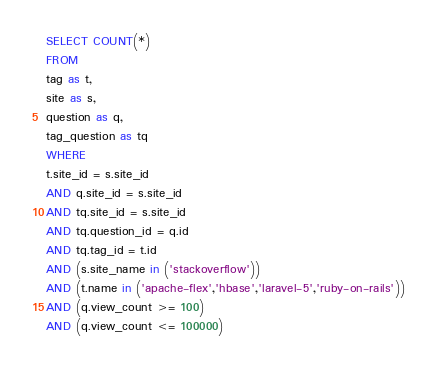<code> <loc_0><loc_0><loc_500><loc_500><_SQL_>SELECT COUNT(*)
FROM
tag as t,
site as s,
question as q,
tag_question as tq
WHERE
t.site_id = s.site_id
AND q.site_id = s.site_id
AND tq.site_id = s.site_id
AND tq.question_id = q.id
AND tq.tag_id = t.id
AND (s.site_name in ('stackoverflow'))
AND (t.name in ('apache-flex','hbase','laravel-5','ruby-on-rails'))
AND (q.view_count >= 100)
AND (q.view_count <= 100000)
</code> 